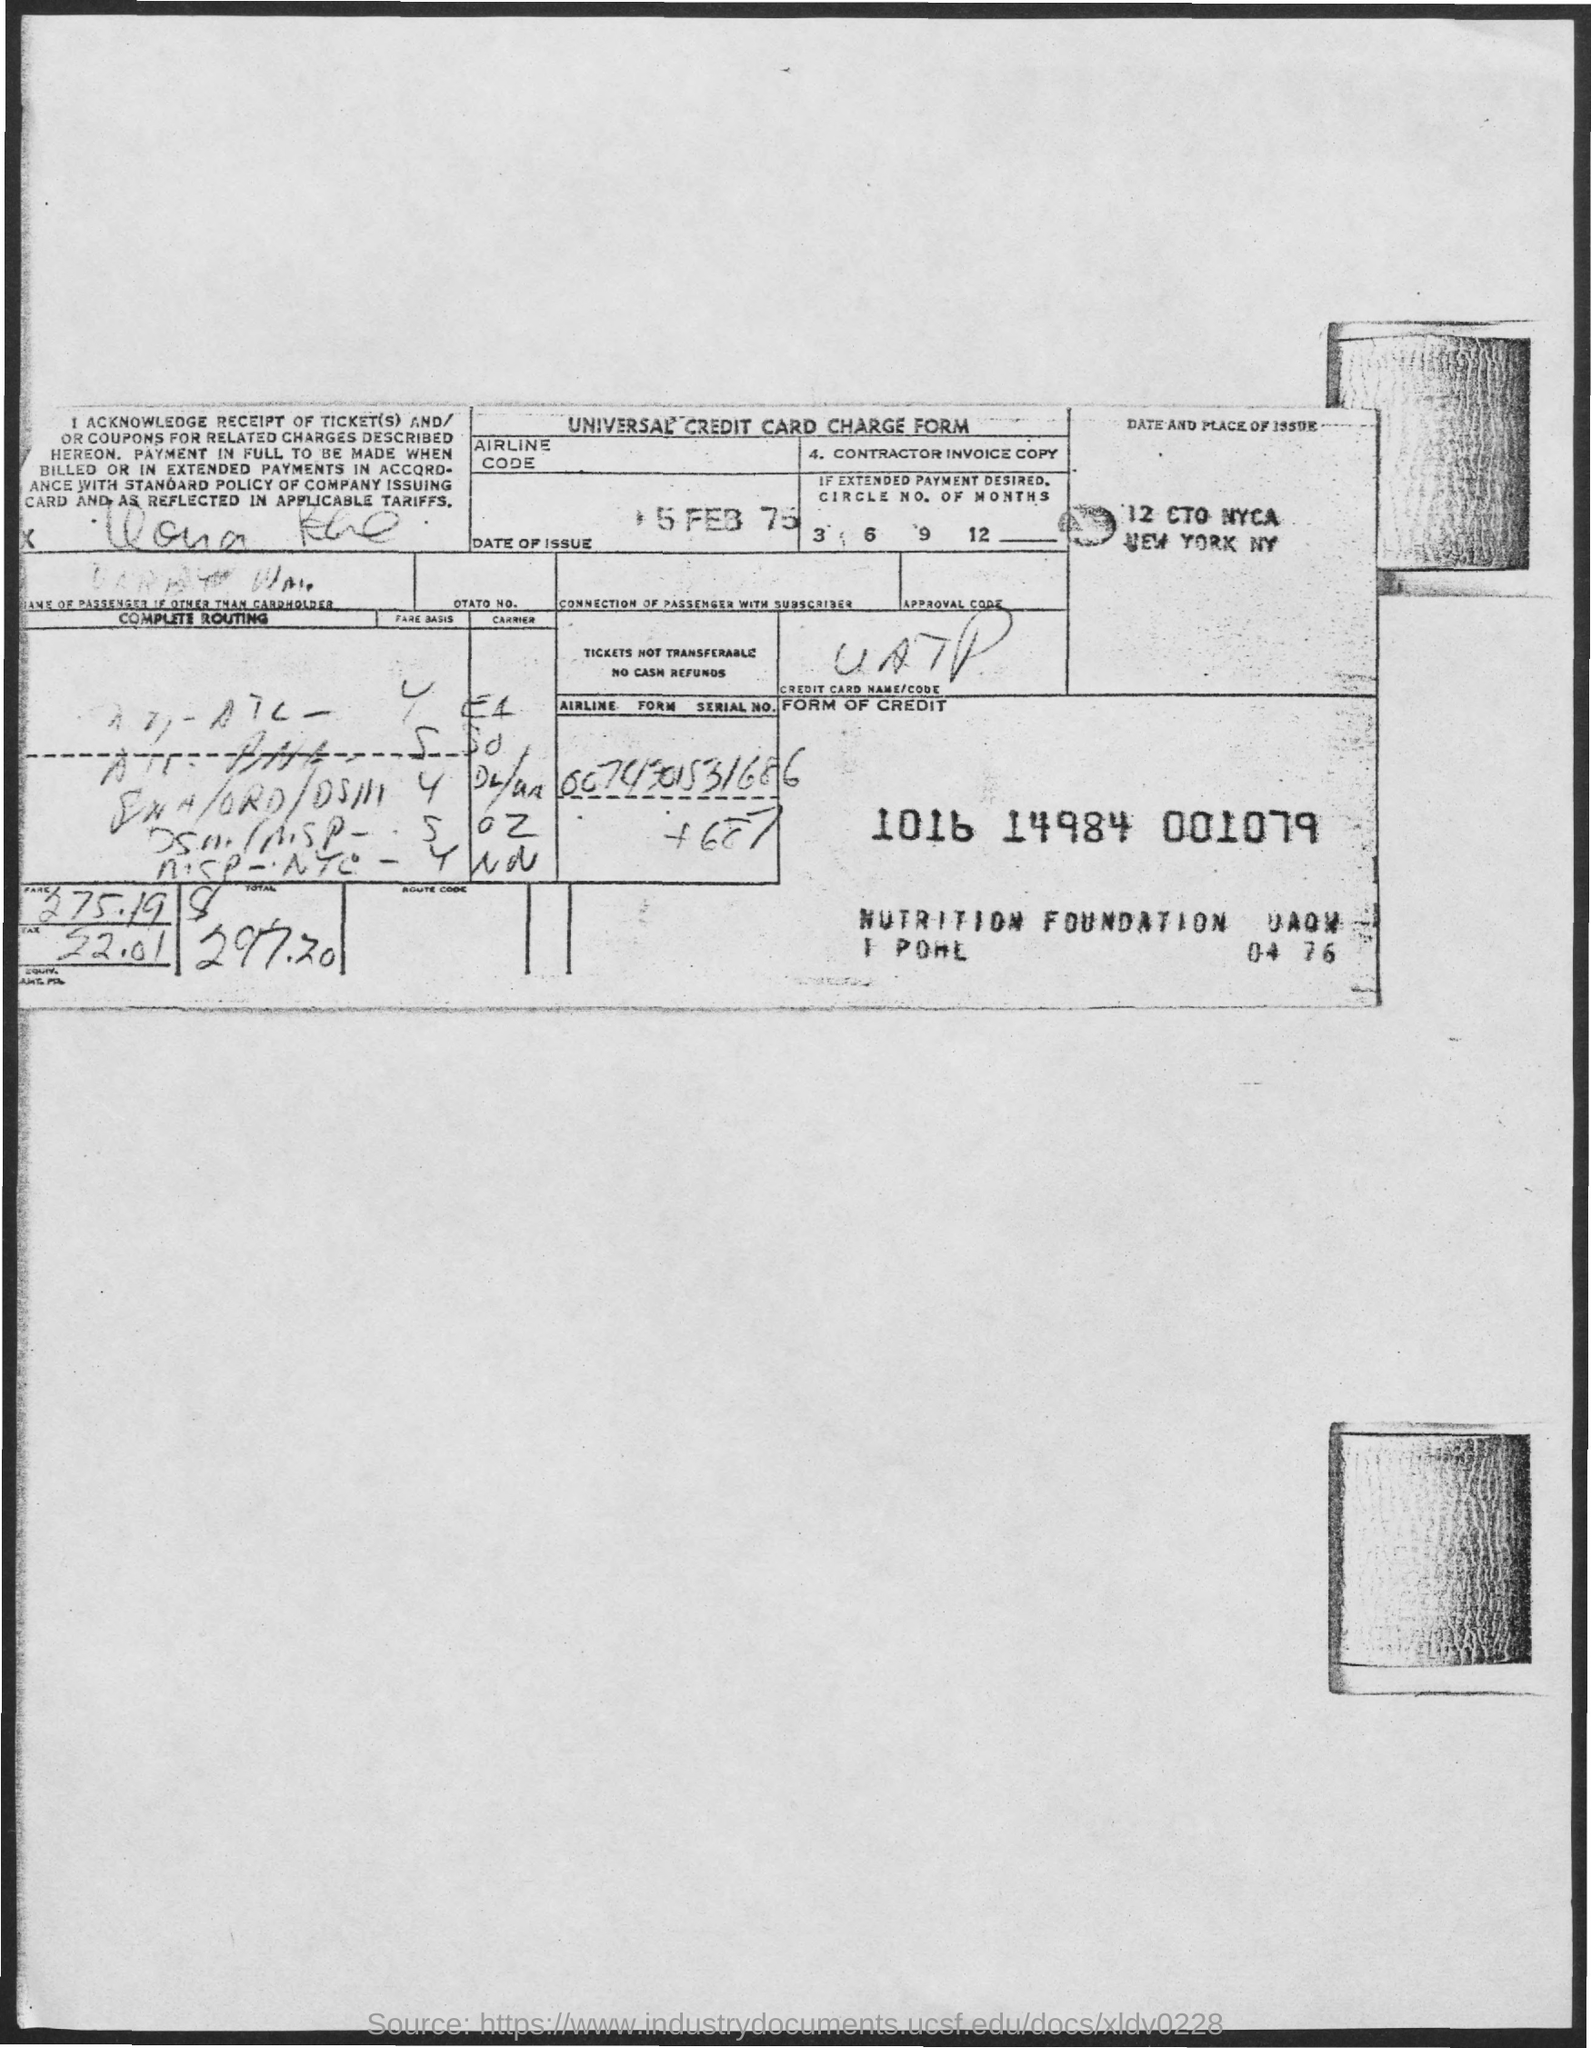What is the tax amount?
Your response must be concise. 52.01. What is the date of the issue?
Give a very brief answer. 5 FEB 75. 